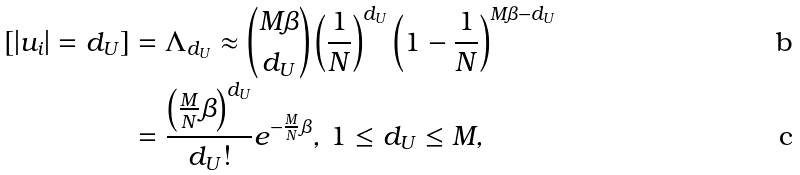<formula> <loc_0><loc_0><loc_500><loc_500>[ | u _ { i } | = d _ { U } ] & = \Lambda _ { d _ { U } } \approx { M \beta \choose d _ { U } } \left ( \frac { 1 } { N } \right ) ^ { d _ { U } } \left ( 1 - \frac { 1 } { N } \right ) ^ { M \beta - d _ { U } } \\ & = \frac { \left ( \frac { M } { N } \beta \right ) ^ { d _ { U } } } { d _ { U } ! } e ^ { - \frac { M } { N } \beta } , \, 1 \leq d _ { U } \leq M ,</formula> 